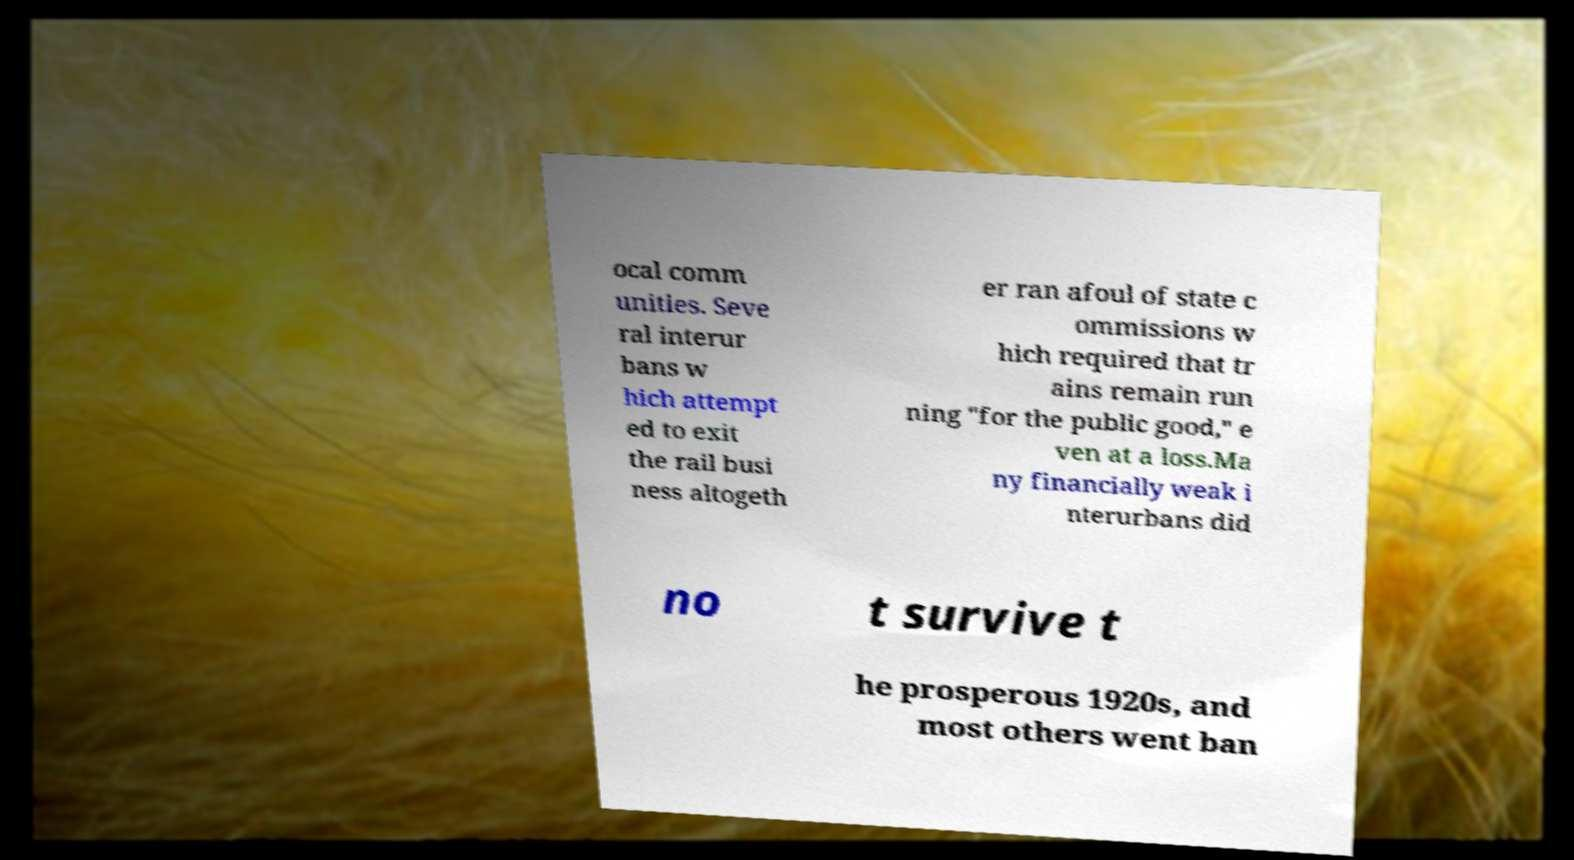Can you accurately transcribe the text from the provided image for me? ocal comm unities. Seve ral interur bans w hich attempt ed to exit the rail busi ness altogeth er ran afoul of state c ommissions w hich required that tr ains remain run ning "for the public good," e ven at a loss.Ma ny financially weak i nterurbans did no t survive t he prosperous 1920s, and most others went ban 